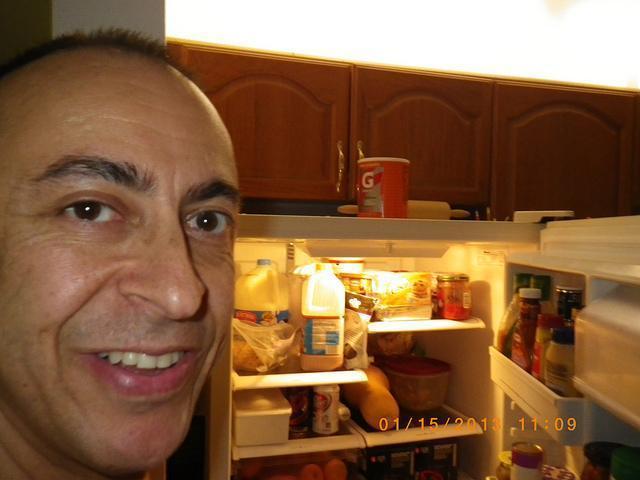How many orange and white cats are in the image?
Give a very brief answer. 0. 